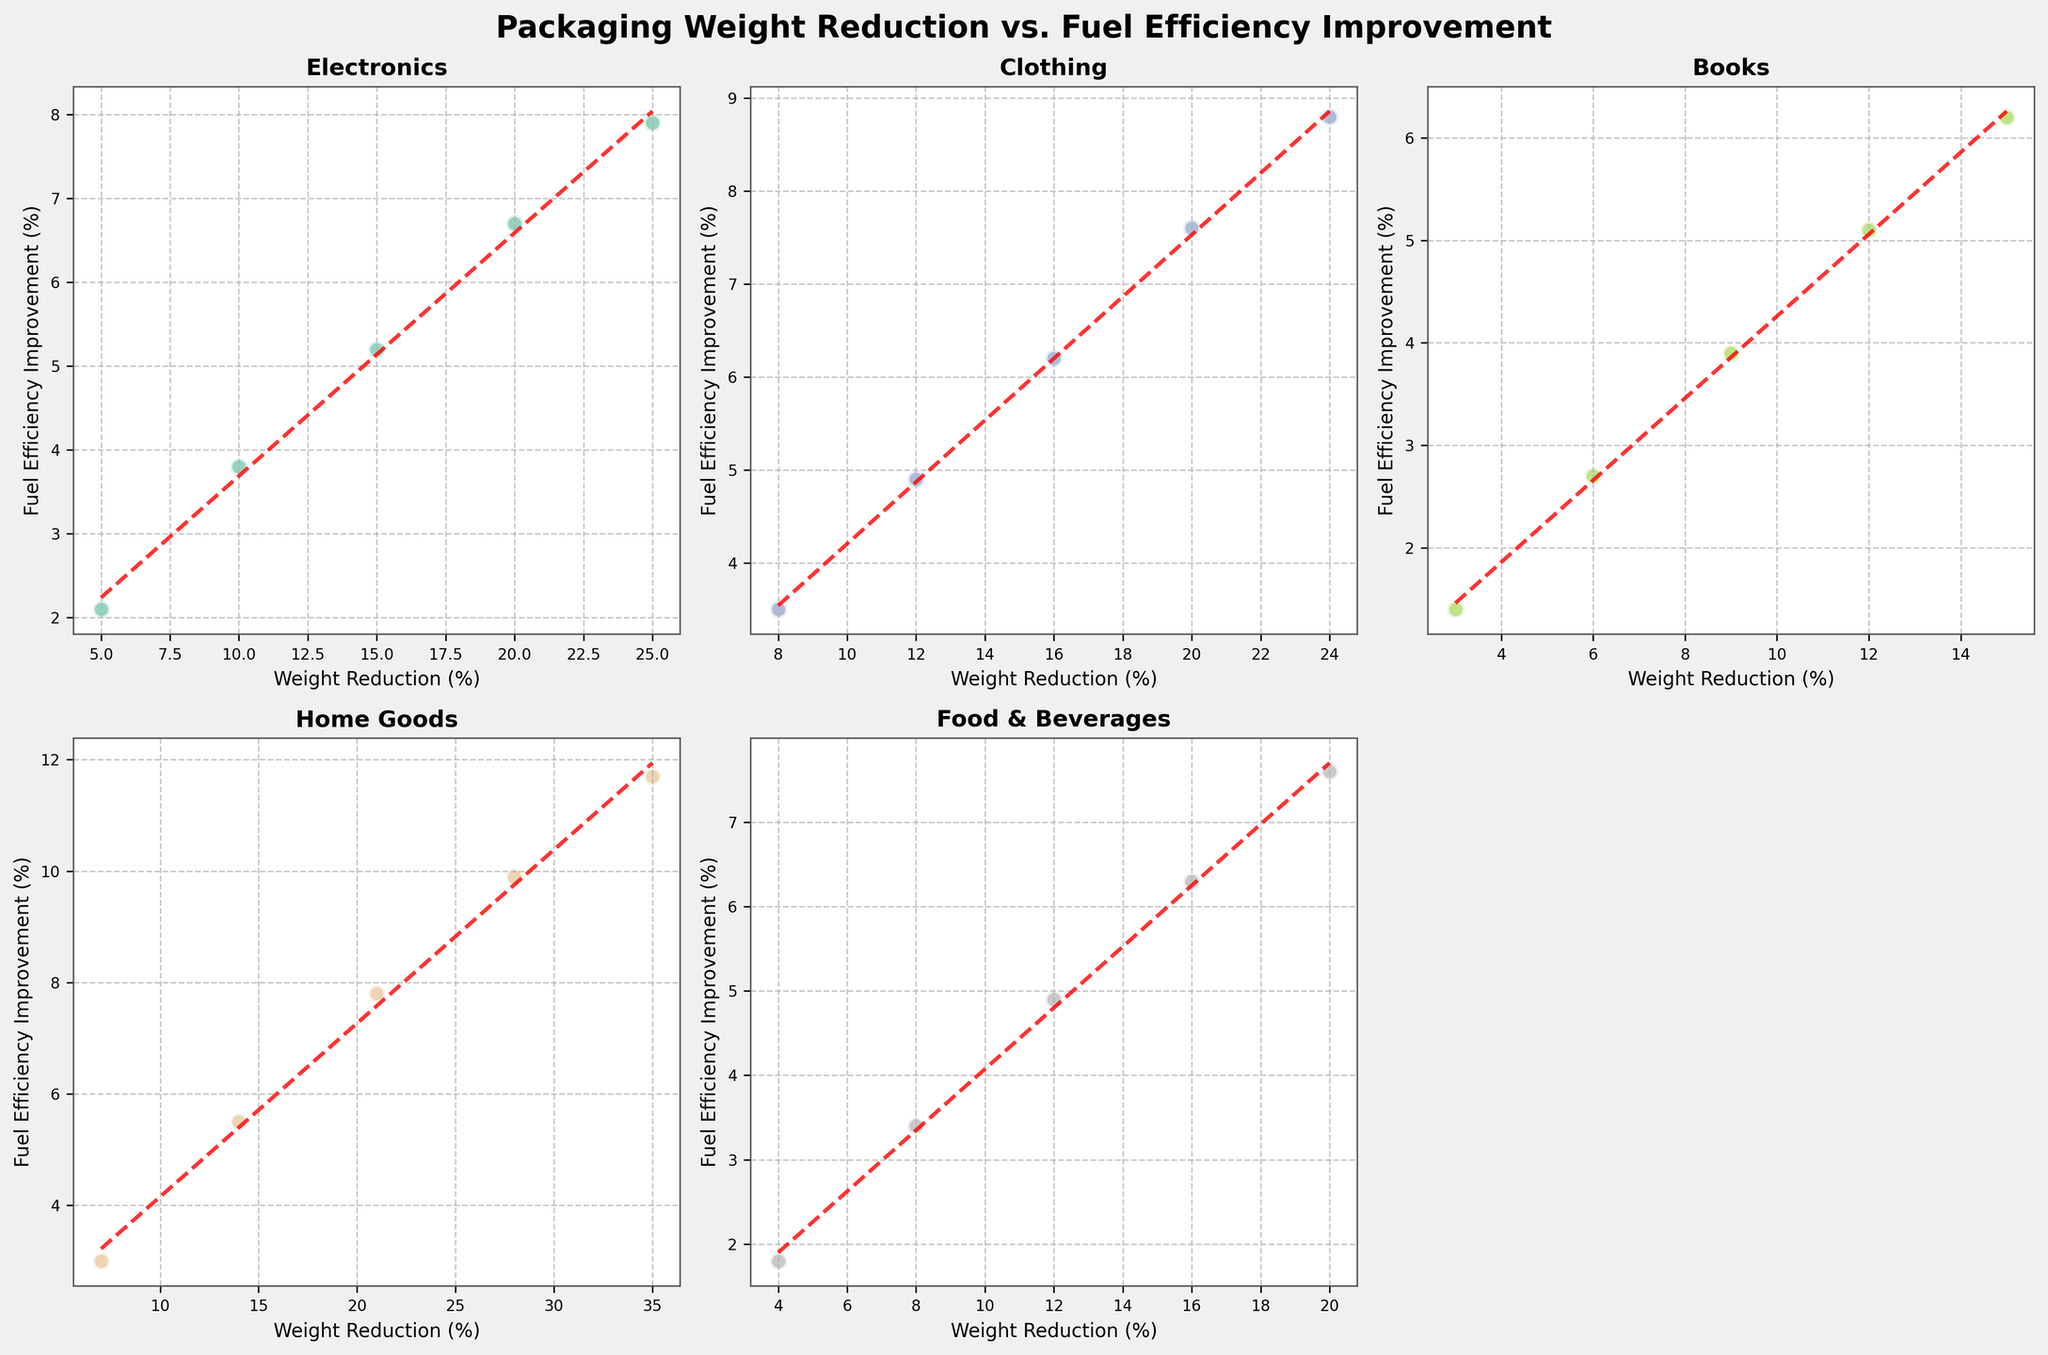How many product categories are shown in the figure? The figure includes subplots for each product category, count the number of unique category titles in the subplots.
Answer: 5 Which product category has the highest maximum weight reduction percentage? Look at the x-axes of all subplots and compare the maximum weight reduction percentage for each category. Home Goods has the highest maximum at 35%.
Answer: Home Goods Which product category shows the least improvement in fuel efficiency at the lowest weight reduction percentage point? Examine the y-axis values for the data points at the smallest weight reduction percentage in each subplot. Books have the lowest value at 1.4% improvement.
Answer: Books What's the average fuel efficiency improvement for the Clothing category? Add up all the fuel efficiency improvement percentages in the Clothing category and divide by the number of data points. (3.5 + 4.9 + 6.2 + 7.6 + 8.8) / 5 = 6.2
Answer: 6.2 For the Electronics category, what's the difference in fuel efficiency improvement between the 10% and 20% weight reduction points? Identify the fuel efficiency improvement values at both 10% (3.8) and 20% (6.7) weight reduction points, then subtract the lower from the higher: 6.7 - 3.8 = 2.9.
Answer: 2.9 Which product category has the steepest positive trend line between weight reduction and fuel efficiency improvement? Look at the slopes of the trend lines in each subplot; the one with the steepest positive slope corresponds to the steepest improved fuel efficiency. Home Goods shows the steepest trend.
Answer: Home Goods In which category does a 20% weight reduction lead to a fuel efficiency improvement of approximately 7.6%? Check the data points and trend lines' intersection for approximately 7.6% improvement at 20% weight reduction in each subplot. Both Clothing and Food & Beverages match this criteria.
Answer: Clothing, Food & Beverages How does the Electronics category compare to the Food & Beverages category in terms of the trend of fuel efficiency improvement for the same range of weight reduction? Compare both trend lines visually from 5% to 20% weight reduction. Electronics shows a more gradual increase while Food & Beverages shows a steeper trend.
Answer: Electronics is more gradual, Food & Beverages is steeper What is the range of fuel efficiency improvement percentages for the Home Goods category? Identify the lowest (3.0) and highest (11.7) fuel efficiency improvement values, then find their range: 11.7 - 3.0 = 8.7.
Answer: 8.7 